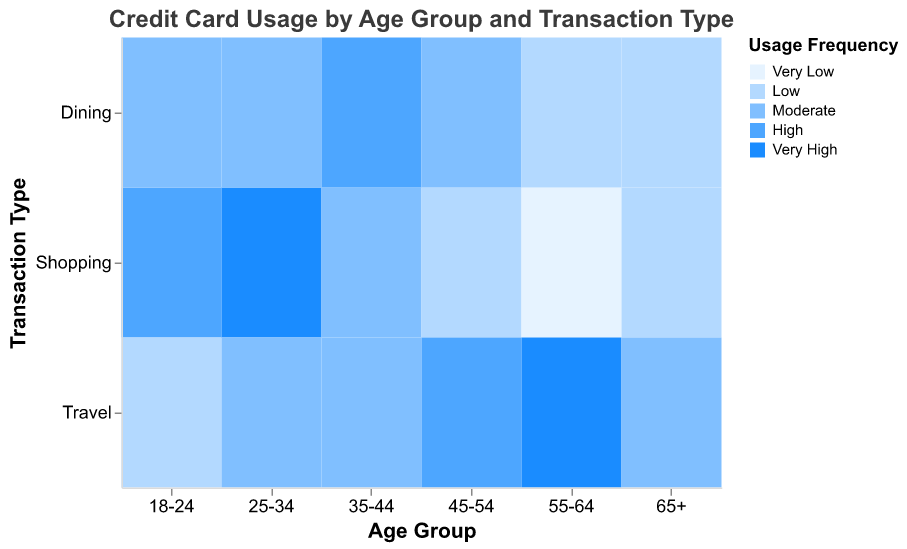What's the title of the heatmap? The title of the heatmap is located at the top and is clearly labeled.
Answer: Credit Card Usage by Age Group and Transaction Type Which age group has the highest frequency of using credit cards for shopping? The color for the highest frequency (Very High) is dark blue, and the age group with this color for Shopping is 25-34.
Answer: 25-34 Which age group shows a Very Low usage frequency for shopping? Very Low usage is represented by the lightest blue color, and the age group with this color for Shopping is 55-64.
Answer: 55-64 Which transaction type is most frequently used by the 35-44 age group? For the 35-44 age group, the darkest blue color indicates the highest usage frequency. Dining is colored dark blue for this age group, indicating it has the highest usage frequency.
Answer: Dining Compare the credit card usage frequency for travel between the 55-64 and 25-34 age groups. The color for the 55-64 age group for Travel is the darkest blue (Very High), while the 25-34 age group has a lighter shade indicating a Moderate usage frequency. Very High is greater than Moderate.
Answer: 55-64 has a higher frequency How does the usage frequency for dining compare between the youngest (18-24) and the oldest (65+) age groups? The 18-24 age group has a Moderate frequency (medium blue) for Dining, while the 65+ age group has a Low frequency (lighter blue). Moderate is higher than Low.
Answer: 18-24 has a higher frequency Which two age groups have a moderate frequency of travel usage? The color representing Moderate usage frequency is a medium shade of blue. The age groups with this color for Travel are 25-34 and 35-44.
Answer: 25-34 and 35-44 How many transaction types have a High usage frequency for the 45-54 age group? For the 45-54 age group, the dark blue color indicates High frequency, and it appears once, for Travel.
Answer: One What is the range of usage frequencies used in the heatmap? The legend indicates the range of usage frequencies from Very Low (lightest blue) to Very High (darkest blue).
Answer: Very Low to Very High 